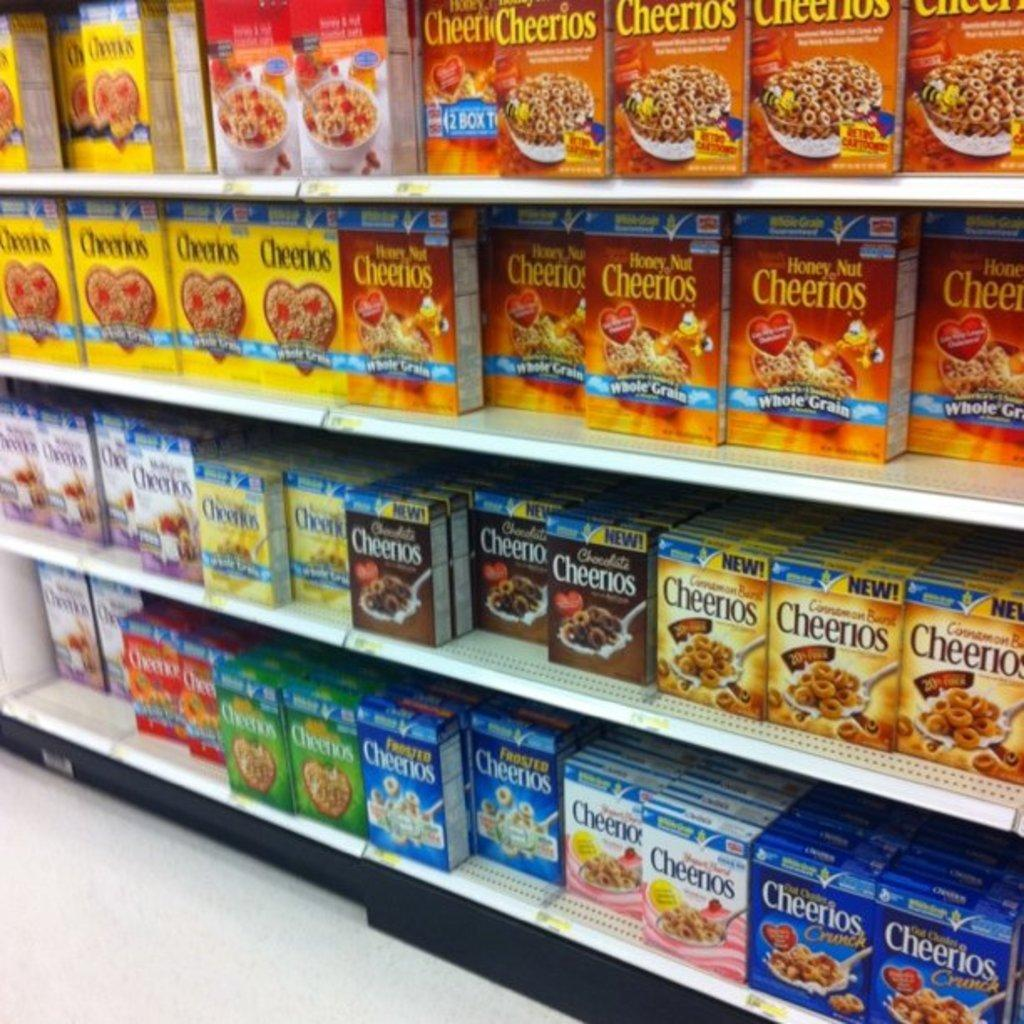<image>
Summarize the visual content of the image. Different varieties of Cheerios cereal are displayed on grocery store shelves. 